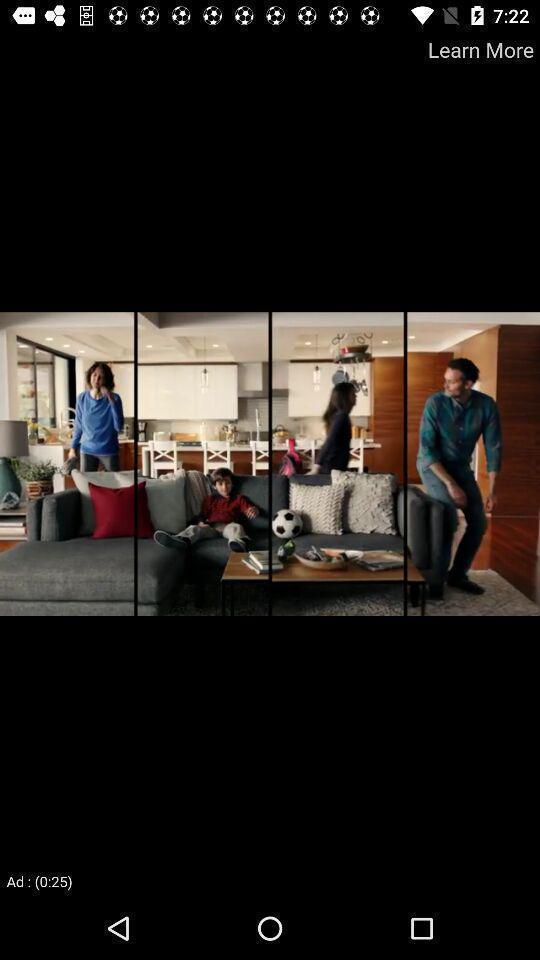Describe this image in words. Screen shows the image of advertisement on a application. 